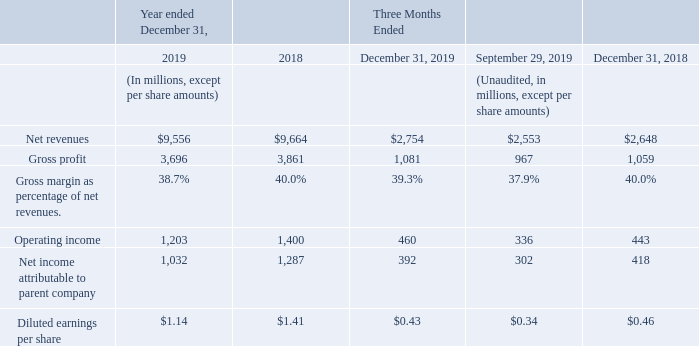The total available market is defined as the “TAM”, while the serviceable available market, the “SAM”, is defined as the market for products sold by us (which consists of the TAM and excludes major devices such as Microprocessors (“MPUs”), Dynamic random-access memories (“DRAMs”), optoelectronics devices, Flash Memories and the Wireless Application Specific market products such as Baseband and Application Processor).
Based on industry data published by WSTS, semiconductor industry revenues in 2019 decreased on a year-over-year basis by approximately 12% for the TAM, while it remains substantially flat for the SAM, to reach approximately $412 billion and $194 billion, respectively. In the fourth quarter of 2019, on a year-overyear basis, the TAM decreased by approximately 6%, while the SAM increased by approximately 2%. Sequentially, the TAM increased by approximately 1%, while the SAM decreased by approximately 3%.
Our 2019 financial performance, with net revenues of $9.56 billion, gross margin of 38.7% and operating margin of 12.6% is aligned with the full year expectations we provided in April 2019.
We closed 2019 with a solid fourth quarter sales and financial performance. In the fourth quarter, net revenues were up 4.0% year-over-year, gross margin reached 39.3%, and operating margin was 16.7%. On a sequential basis, fourth quarter revenues grew by 7.9%, with all product group contributing to the growth, and 290 basis points above the mid-point of our guidance. Our quarterly performance was above the SAM both sequentially and on a year-over-year basis.
Our effective average exchange rate was $1.14 for €1.00 for the full year 2019, as compared to $1.18 for €1.00 for the full year 2018. Our effective average exchange rate for the fourth quarter of 2019 was $1.12 for €1.00, compared to $1.14 for €1.00 for the third quarter of 2019 and $1.17 for €1.00 in the fourth quarter of 2018. For a more detailed discussion of our hedging arrangements and the impact of fluctuations in exchange rates, see “Impact of Changes in Exchange Rates”.
Our 2019 gross margin decreased 130 basis points to 38.7% from 40.0% in 2018 mainly due to normal price pressure and increased unsaturation charges, partially offset by improved manufacturing efficiencies, better product mix, and favorable currency effects, net of hedging.
Our fourth quarter 2019 gross margin was 39.3%, 110 basis points above the mid-point of our guidance, improving sequentially by 140 basis points, mainly driven by improved product mix and better manufacturing efficiencies. Our gross margin decreased 70 basis points year-over-year, mainly impacted by price pressure and unsaturation charges, partially offset by improved manufacturing efficiencies, better product mix and favorable currency effects, net of hedging.
Our operating expenses, comprised of SG&A and R&D expenses, amounted to $2,591 million in 2019, increasing by about 3.9% from $2,493 million in the prior year, mainly due to salary dynamic, increased spending in certain R&D programs and higher share-based compensation cost, partially offset by favorable currency effects, net of hedging. Combined R&D and SG&A expenses were $672 million for the fourth quarter of 2019, compared to $629 million and $630 million in the prior and year-ago quarters, respectively. The sequential increase was mainly due to seasonality and salary dynamic. The year-over-year increase of operating expenses was mainly due to salary dynamic and increased activity on certain R&D programs, and was partially offset by favorable currency effects, net of hedging.
Other income and expenses, net, was $103 million in 2019 compared to $53 million in 2018, mainly due to a higher level of R&D grants, mainly benefitting from the grants associated with the programs part of the European Commission IPCEI in Italy and in France. Fourth quarter other income and expenses, net, was $54 million compared to negative $2 million in the prior quarter and $16 million in the year-ago quarter, reflecting higher R&D grants in Italy associated with the IPCEI program.
In 2019, impairment and restructuring charges were $5 million compared to $21 million in 2018. Impairment and restructuring charges in the fourth quarter were $3 million compared to nil in the prior quarter and $2 million in the year-ago quarters.
Operating income in 2019 was $1,203 million, decreasing by $197 million compared to 2018, mainly driven by normal price pressure, increased unsaturation charges and higher R&D spending, partially offset by higher level of grants and favorable currency effects, net of hedging. Operating income in the fourth quarter grew on a sequential and year-over-year basis to $460 million compared to $336 million and $443 million in the prior quarter and year-ago quarters, respectively, mainly driven by higher revenues, improved product mix and a higher level of grants.
What is the full form of TAM? The total available market is defined as the “tam”. What is the full form of SAM? The serviceable available market. What is defined as SAM? The serviceable available market, the “sam”, is defined as the market for products sold by us (which consists of the tam and excludes major devices such as microprocessors (“mpus”), dynamic random-access memories (“drams”), optoelectronics devices, flash memories and the wireless application specific market products such as baseband and application processor). What are the average net revenues for year ended December 31?
Answer scale should be: million. (9,556+9,664) / 2
Answer: 9610. What is the increase/ (decrease) in net revenues for year ended December 31, from 2018 to 2019?
Answer scale should be: million. 9,556-9,664
Answer: -108. What is the increase/ (decrease) in gross profit for year ended December 31, from 2018 to 2019?
Answer scale should be: million. 3,696-3,861
Answer: -165. 